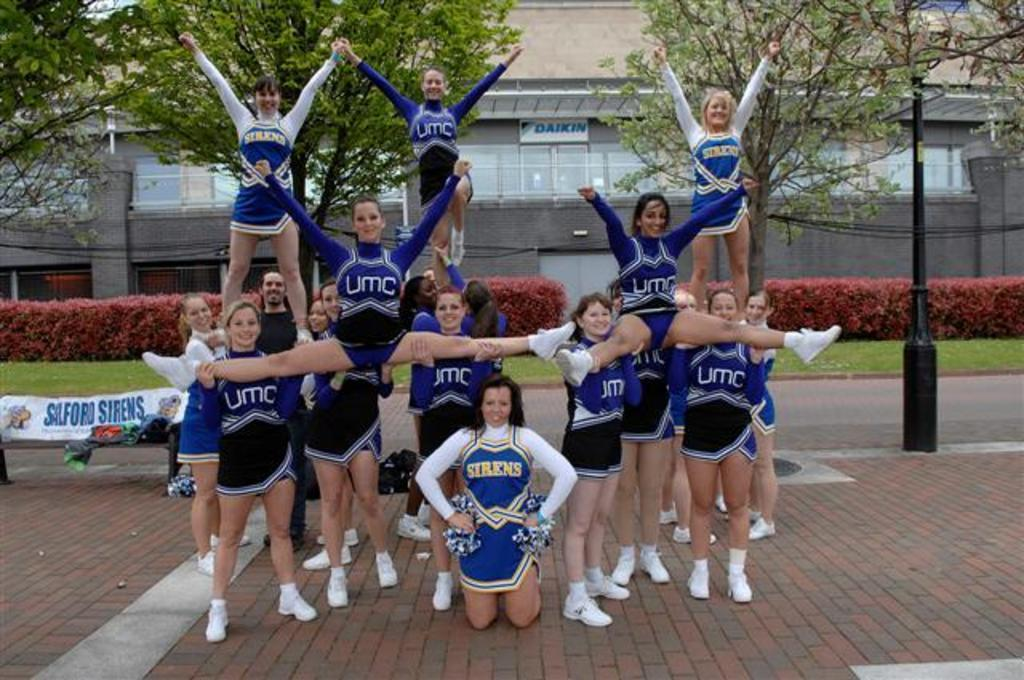<image>
Summarize the visual content of the image. A group of cheerleaders have UMC or sirens on their uniforms. 